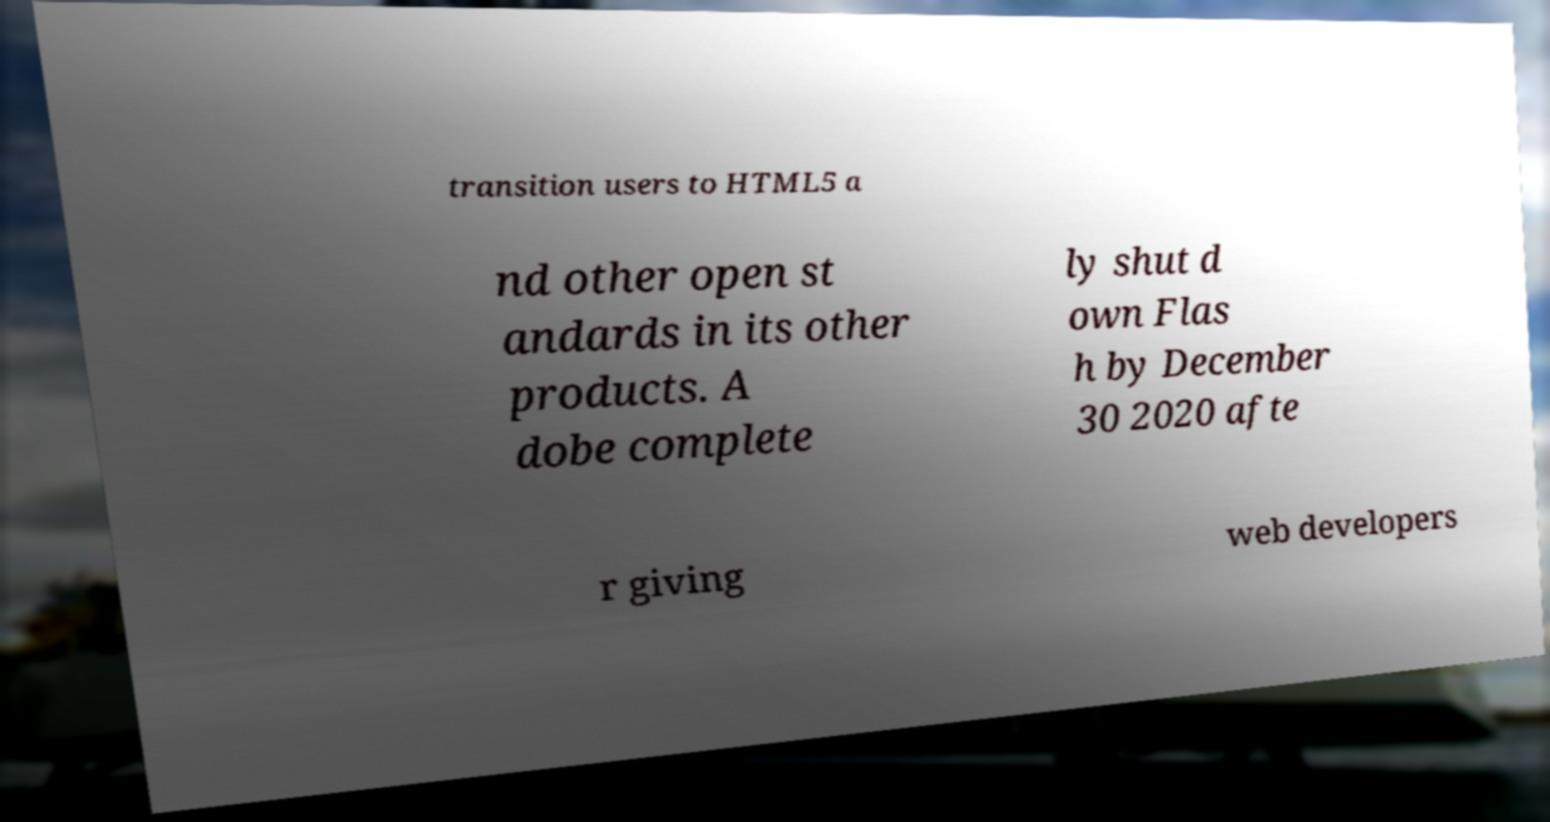There's text embedded in this image that I need extracted. Can you transcribe it verbatim? transition users to HTML5 a nd other open st andards in its other products. A dobe complete ly shut d own Flas h by December 30 2020 afte r giving web developers 